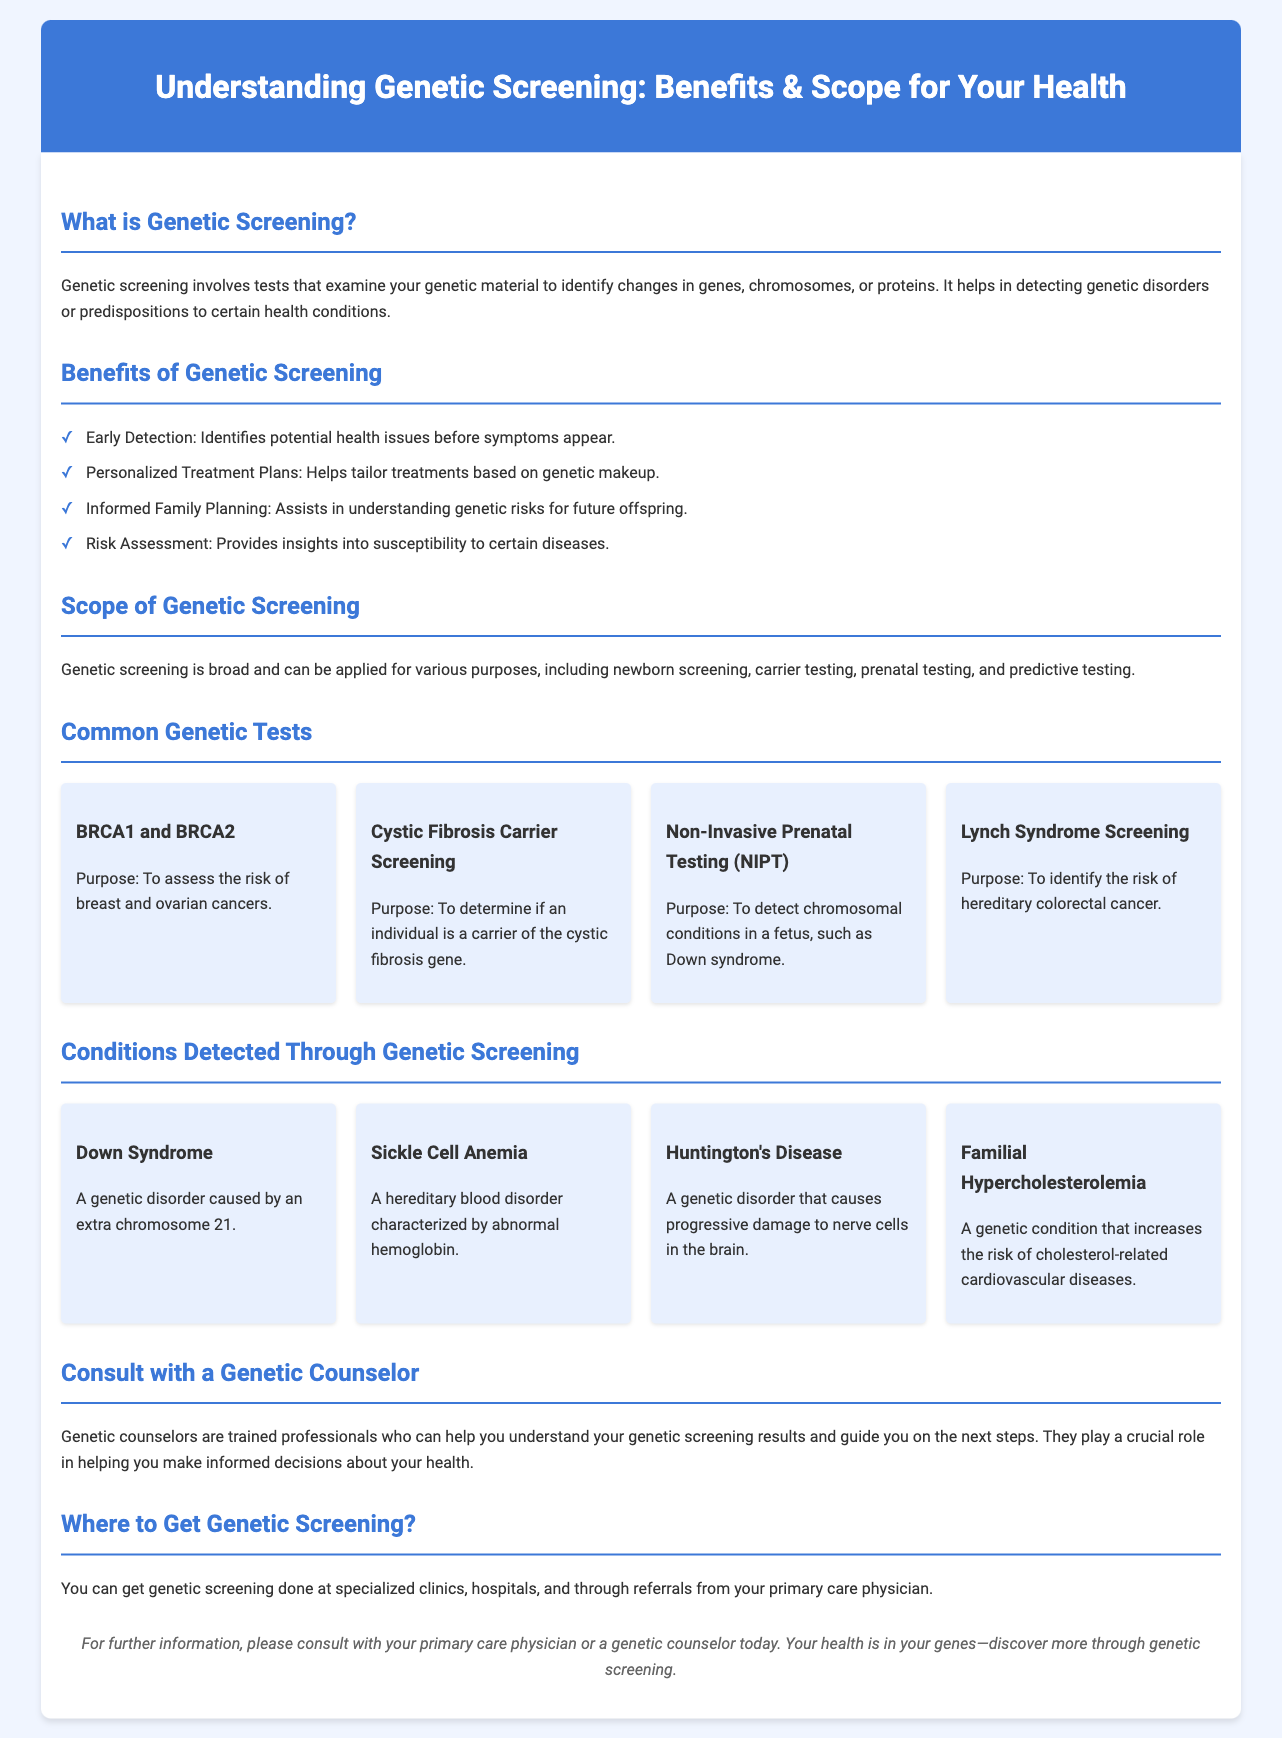What is genetic screening? Genetic screening involves tests that examine your genetic material to identify changes in genes, chromosomes, or proteins.
Answer: Tests that examine genetic material What are the benefits of genetic screening? The benefits include early detection, personalized treatment plans, informed family planning, and risk assessment.
Answer: Early detection, personalized treatment plans, informed family planning, risk assessment What is the purpose of BRCA1 and BRCA2 testing? The purpose is to assess the risk of breast and ovarian cancers.
Answer: Assess the risk of breast and ovarian cancers Which genetic condition is caused by an extra chromosome 21? This condition is Down Syndrome.
Answer: Down Syndrome Who can help you understand genetic screening results? Genetic counselors are trained professionals who can help you understand your genetic screening results.
Answer: Genetic counselors How many common genetic tests are listed in the brochure? There are four common genetic tests listed in the brochure.
Answer: Four What is the main goal of genetic screening related to family planning? It assists in understanding genetic risks for future offspring.
Answer: Understanding genetic risks for future offspring Where can you get genetic screening done? Genetic screening can be done at specialized clinics, hospitals, and through referrals from your primary care physician.
Answer: Specialized clinics, hospitals, referrals from physicians 